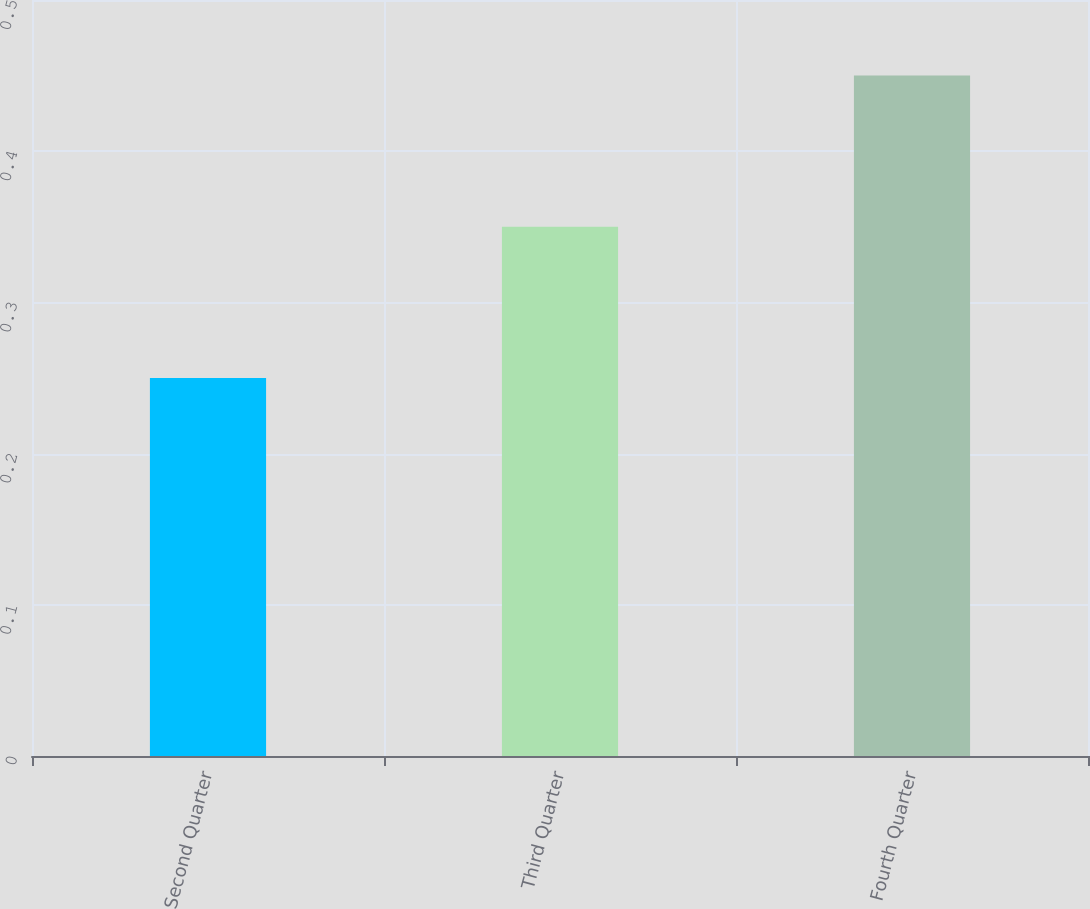Convert chart. <chart><loc_0><loc_0><loc_500><loc_500><bar_chart><fcel>Second Quarter<fcel>Third Quarter<fcel>Fourth Quarter<nl><fcel>0.25<fcel>0.35<fcel>0.45<nl></chart> 